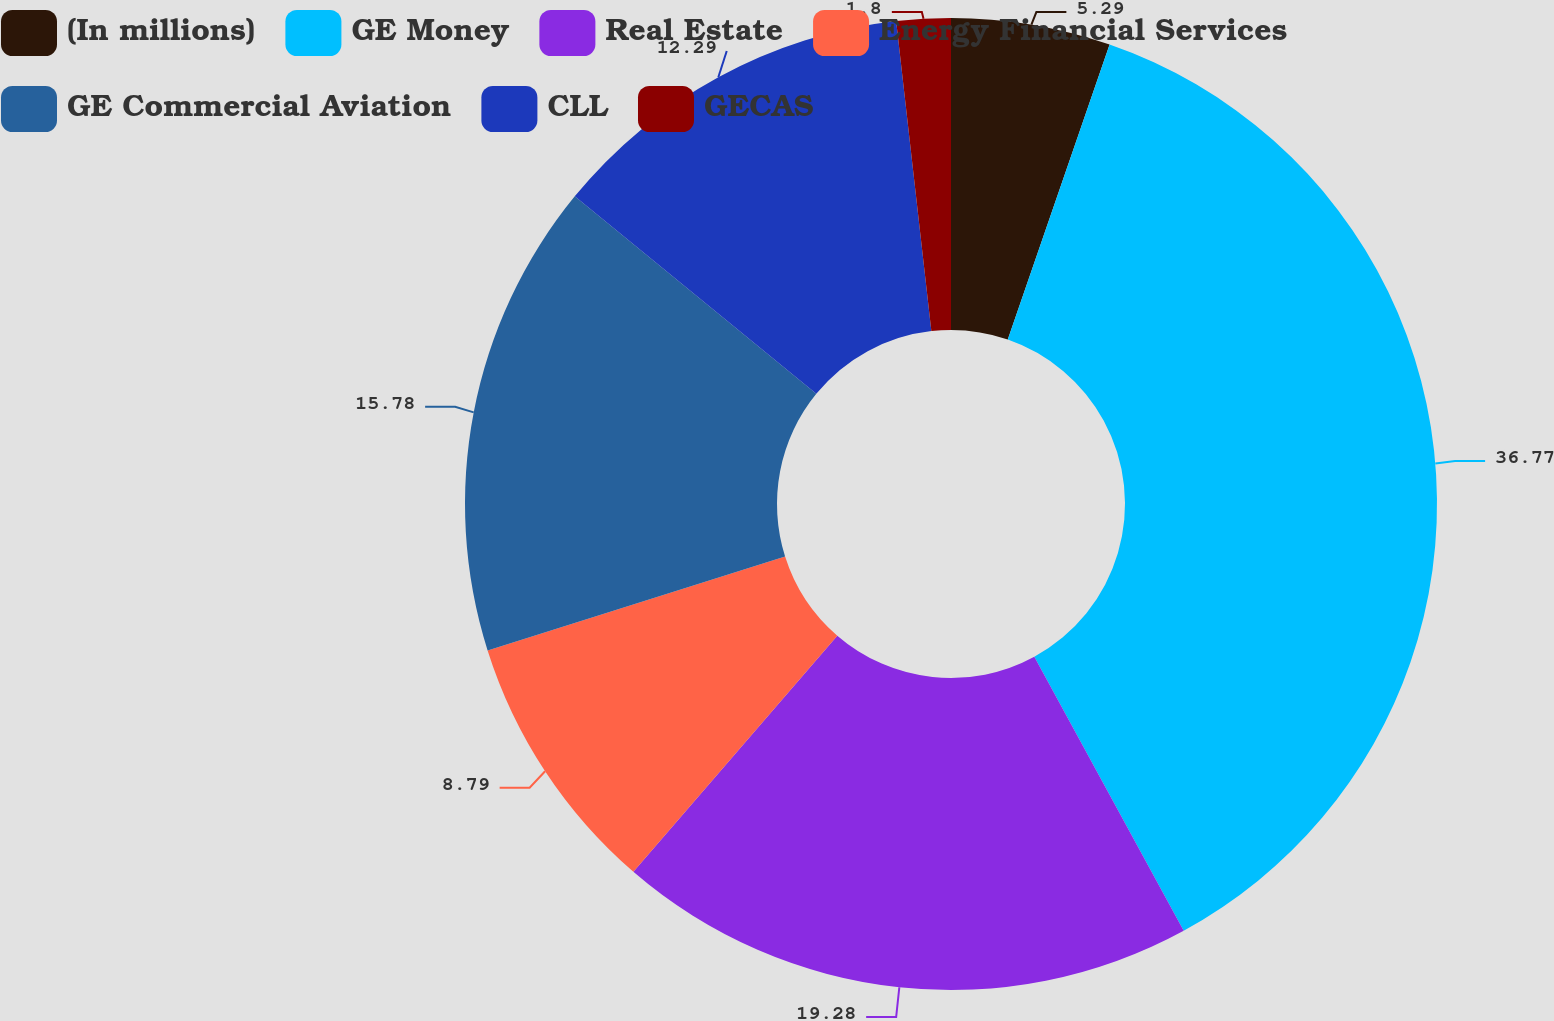Convert chart to OTSL. <chart><loc_0><loc_0><loc_500><loc_500><pie_chart><fcel>(In millions)<fcel>GE Money<fcel>Real Estate<fcel>Energy Financial Services<fcel>GE Commercial Aviation<fcel>CLL<fcel>GECAS<nl><fcel>5.29%<fcel>36.76%<fcel>19.28%<fcel>8.79%<fcel>15.78%<fcel>12.29%<fcel>1.8%<nl></chart> 